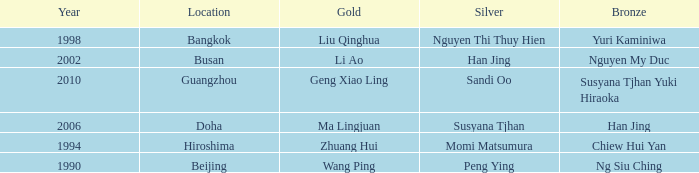What Gold has the Year of 2006? Ma Lingjuan. 